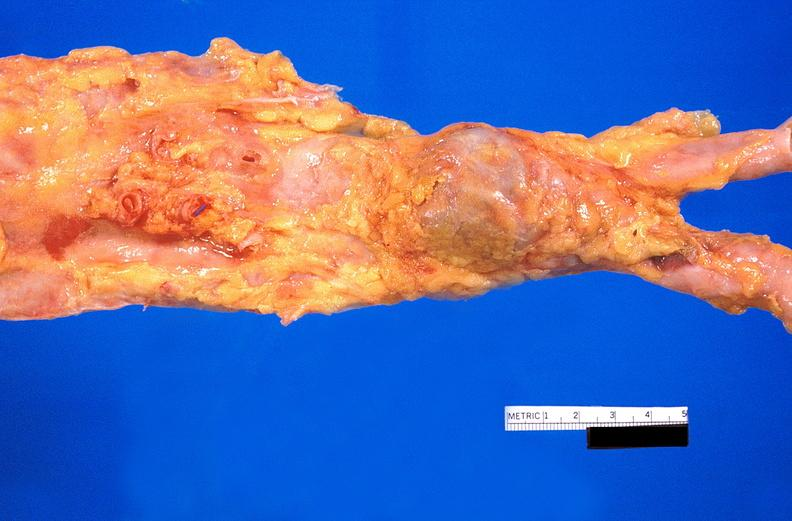s atherosclerosis present?
Answer the question using a single word or phrase. No 